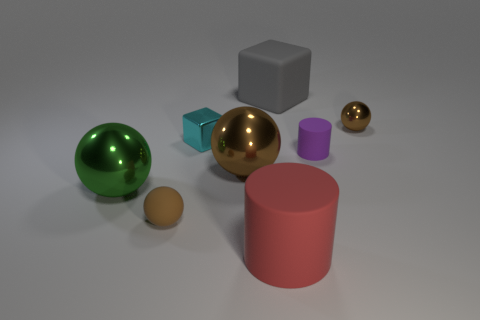What size is the cyan metal thing that is the same shape as the large gray rubber object?
Provide a succinct answer. Small. How many small cyan blocks are there?
Keep it short and to the point. 1. Is the shape of the large brown object the same as the tiny brown thing that is on the left side of the large gray block?
Make the answer very short. Yes. What size is the brown shiny sphere that is to the right of the purple rubber thing?
Offer a very short reply. Small. What material is the purple cylinder?
Give a very brief answer. Rubber. There is a small matte object that is behind the big brown metallic ball; is its shape the same as the big red object?
Your answer should be very brief. Yes. The metal object that is the same color as the small metal ball is what size?
Keep it short and to the point. Large. Is there a purple ball of the same size as the purple matte cylinder?
Your answer should be very brief. No. There is a tiny brown thing that is in front of the small rubber object that is behind the brown matte ball; is there a large thing that is left of it?
Offer a terse response. Yes. There is a rubber ball; is its color the same as the large ball right of the green thing?
Keep it short and to the point. Yes. 